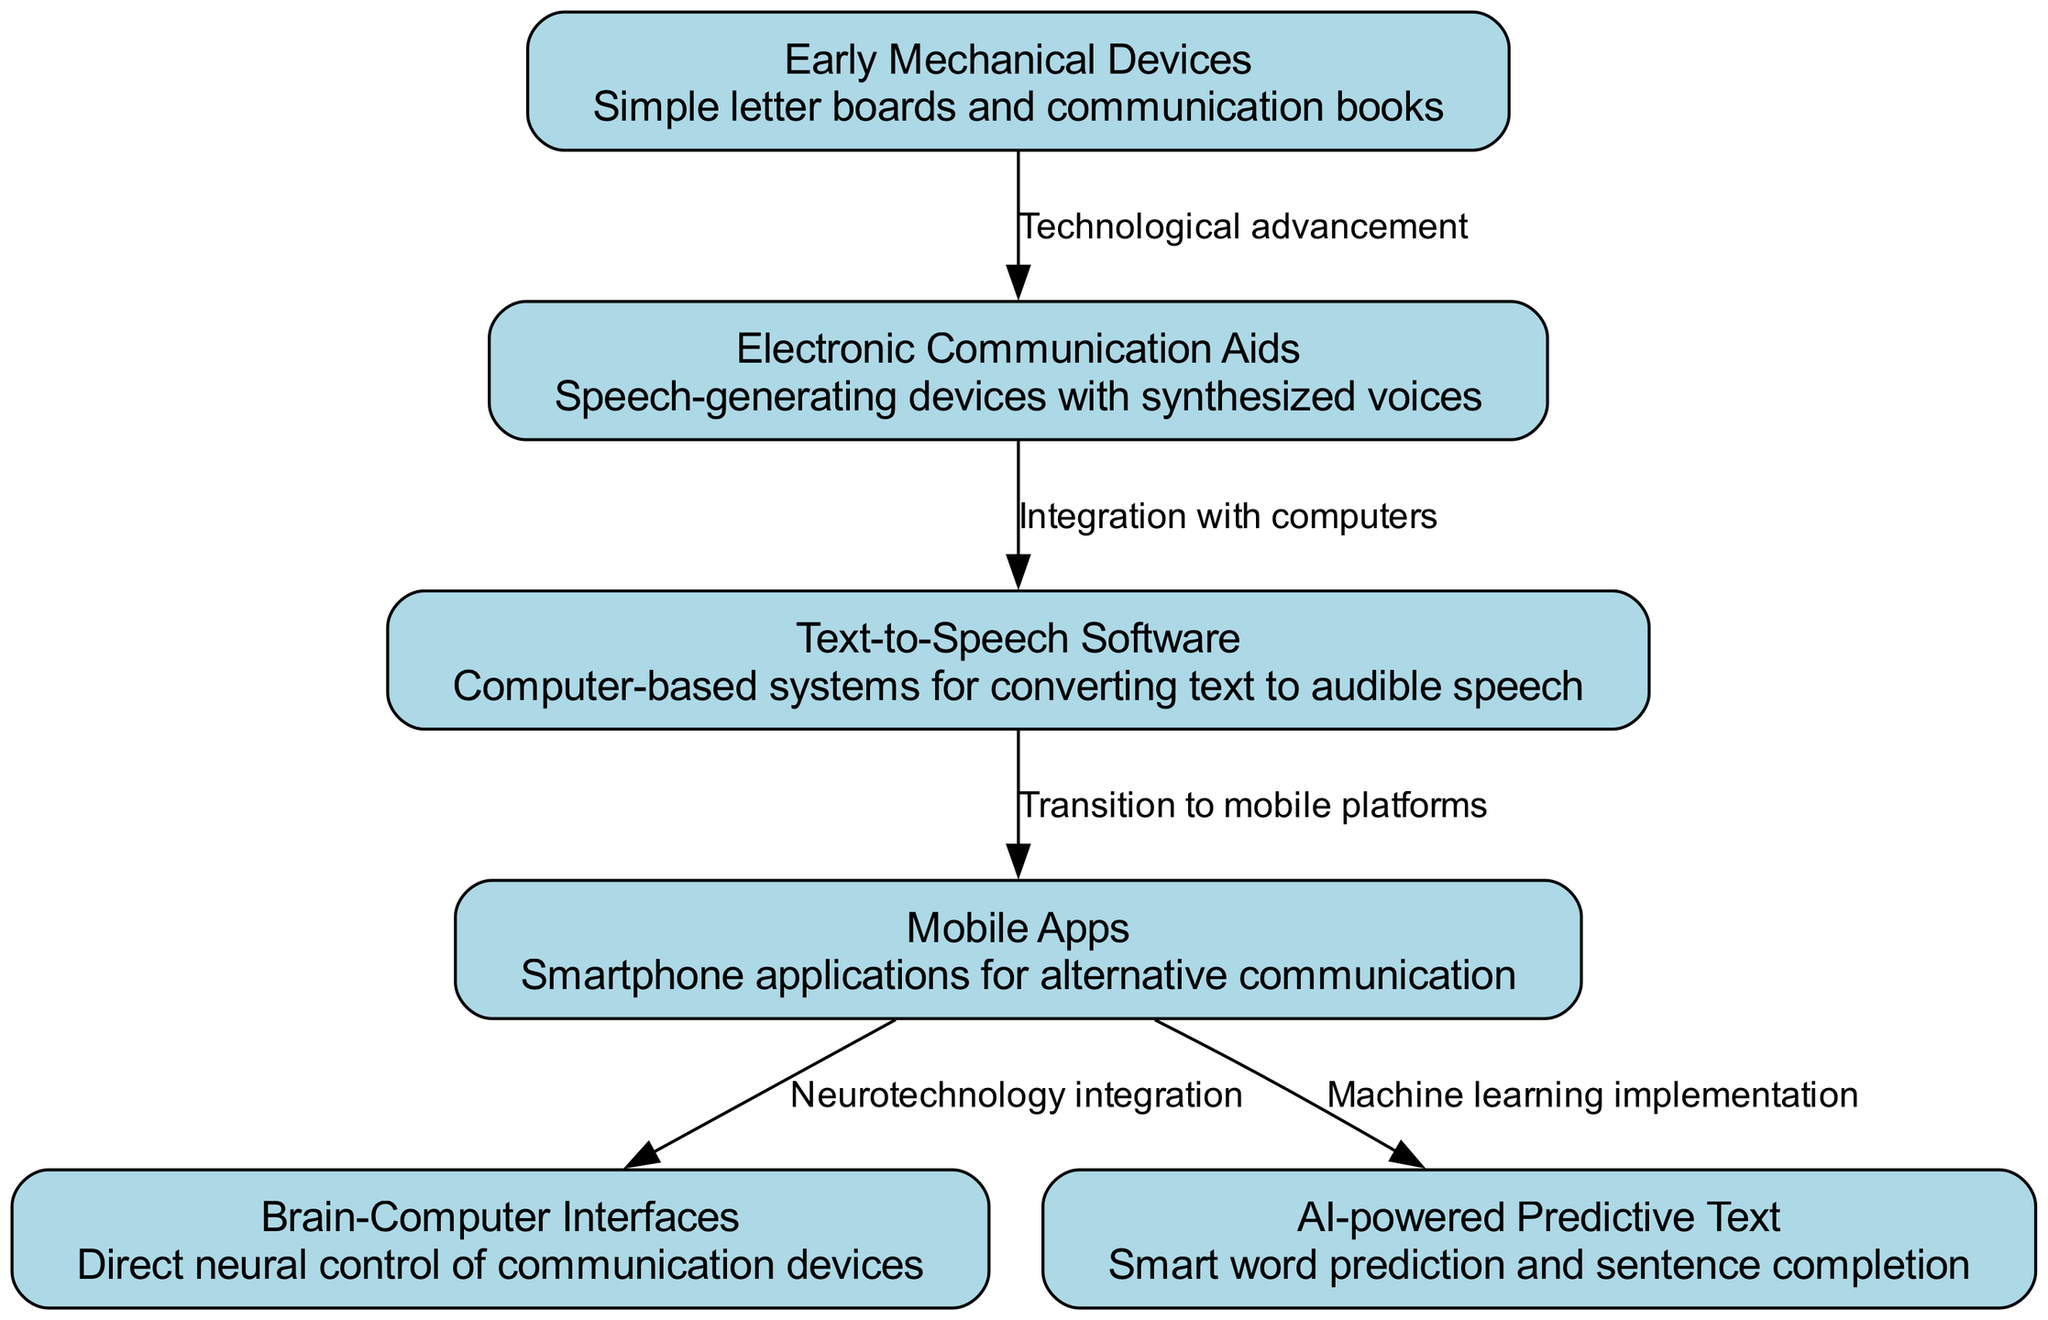What is the first node in the diagram? The first node listed in the data provided is "Early Mechanical Devices", which is represented at the top of the diagram.
Answer: Early Mechanical Devices How many nodes are in the diagram? By counting the entries in the "nodes" section of the provided data, there are a total of 6 nodes.
Answer: 6 What relationship exists between the "Electronic Communication Aids" and "Text-to-Speech Software"? The relationship between these two nodes is labeled as "Integration with computers", indicating that the transition from Electronic Communication Aids to Text-to-Speech Software involves computer integration.
Answer: Integration with computers Which nodes directly lead to "Mobile Apps"? Based on the edges, the only node that directly leads to "Mobile Apps" is "Text-to-Speech Software".
Answer: Text-to-Speech Software What is the last node in the diagram? The last node listed in the data is "AI-powered Predictive Text". In terms of progression, it is the final node reached in the evolution flow of the diagram.
Answer: AI-powered Predictive Text How many edges connect to "Mobile Apps"? By examining the connections, "Mobile Apps" has 2 edges directed towards "Brain-Computer Interfaces" and "AI-powered Predictive Text".
Answer: 2 What technological advancement is shown between "Early Mechanical Devices" and "Electronic Communication Aids"? The diagram indicates that the change from "Early Mechanical Devices" to "Electronic Communication Aids" represents a "Technological advancement".
Answer: Technological advancement What is the significance of "Neurotechnology integration" in the diagram? "Neurotechnology integration" is significant as it highlights the progression from "Mobile Apps" to "Brain-Computer Interfaces", showing an evolution towards more direct control of communication devices through neural interfaces.
Answer: Neurotechnology integration Which node represents a transition to mobile platforms? The node that signifies this transition from older technologies to mobile platforms is "Text-to-Speech Software".
Answer: Text-to-Speech Software 